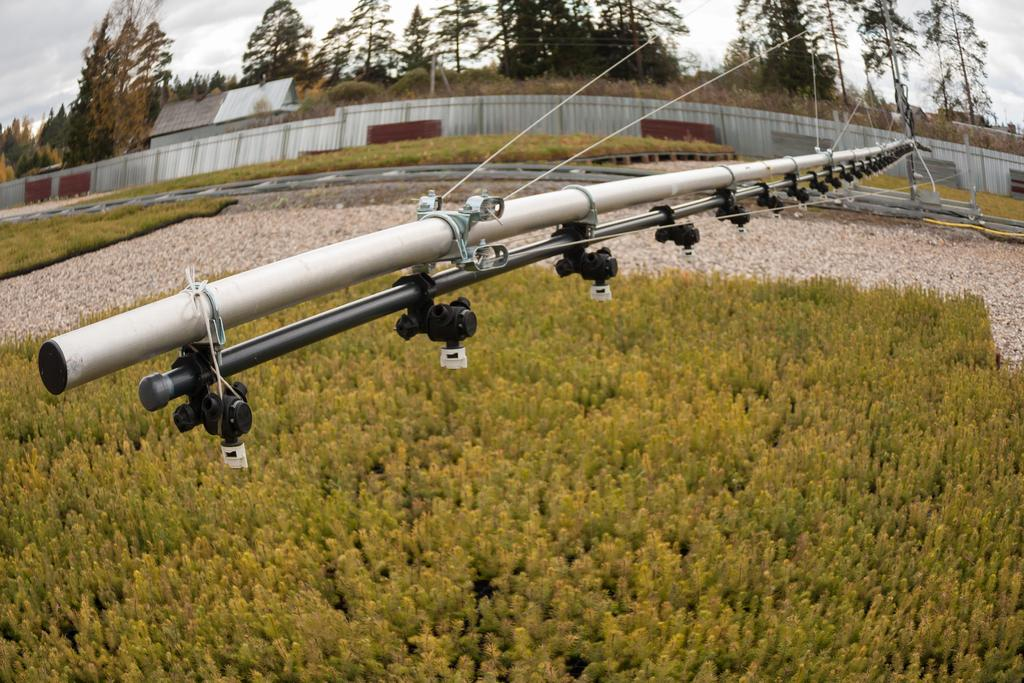What type of vegetation can be seen in the image? There are plants and trees in the image. What type of structure is visible in the image? There is a house in the image. What architectural feature can be seen in the image? There is a wall in the image. What object in the background resembles a pipe? There is an object that looks like a pipe in the background. What is visible at the top of the image? The sky is visible in the image. How many lizards are crawling on the house in the image? There are no lizards present in the image. What type of spoon is being used to stir the plants in the image? There is no spoon present in the image, and the plants are not being stirred. 